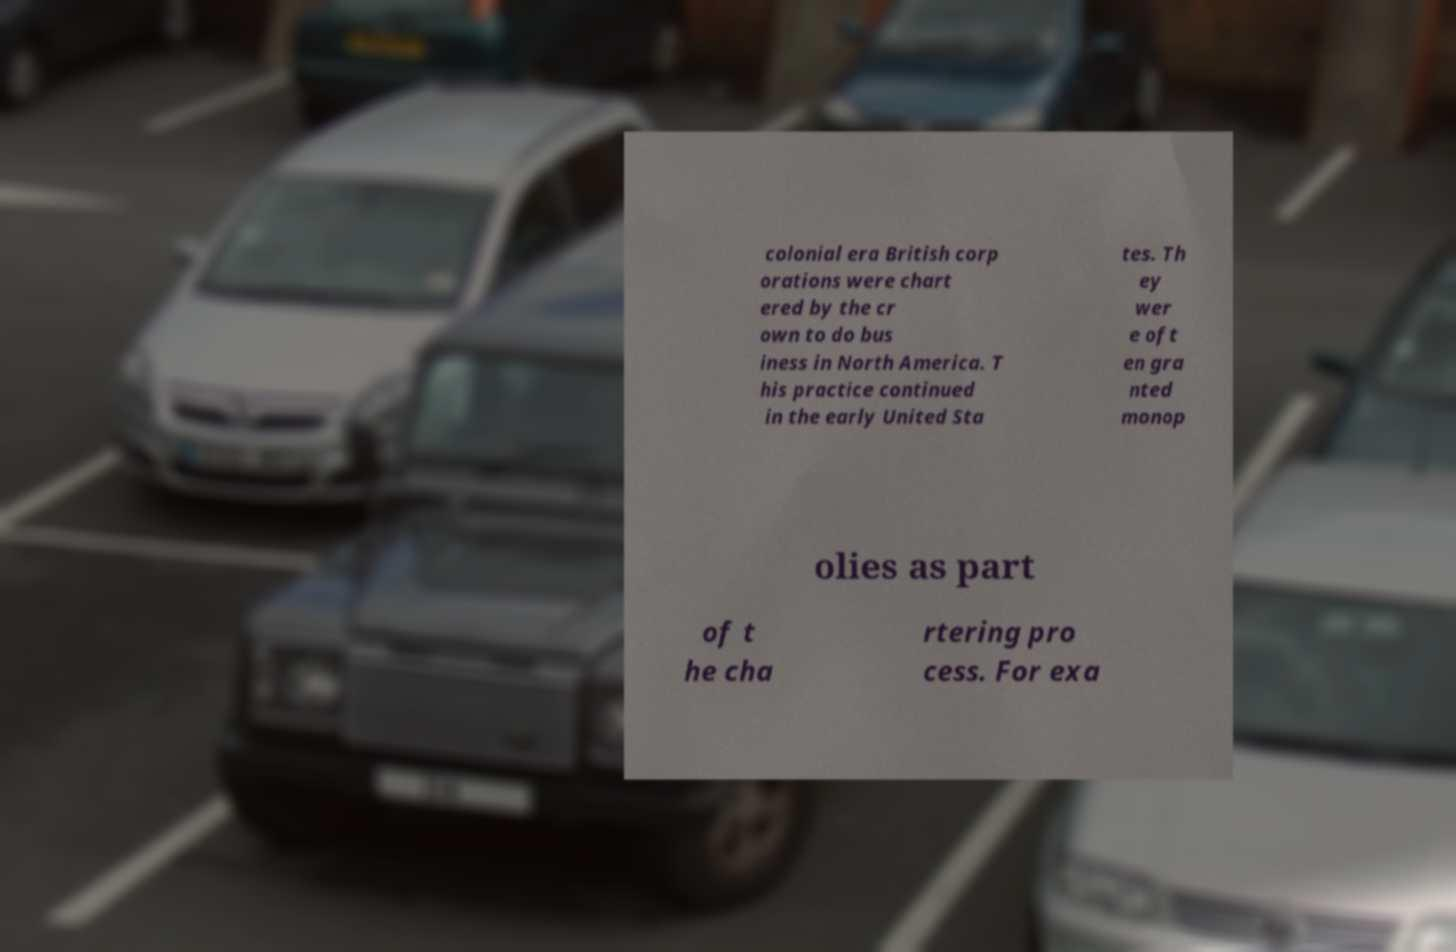Can you read and provide the text displayed in the image?This photo seems to have some interesting text. Can you extract and type it out for me? colonial era British corp orations were chart ered by the cr own to do bus iness in North America. T his practice continued in the early United Sta tes. Th ey wer e oft en gra nted monop olies as part of t he cha rtering pro cess. For exa 